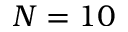<formula> <loc_0><loc_0><loc_500><loc_500>N = 1 0</formula> 